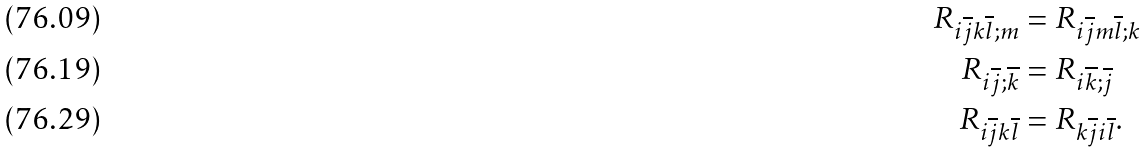Convert formula to latex. <formula><loc_0><loc_0><loc_500><loc_500>R _ { i \overline { j } k \overline { l } ; m } & = R _ { i \overline { j } m \overline { l } ; k } \\ R _ { i \overline { j } ; \overline { k } } & = R _ { i \overline { k } ; \overline { j } } \\ R _ { i \overline { j } k \overline { l } } & = R _ { k \overline { j } i \overline { l } } .</formula> 